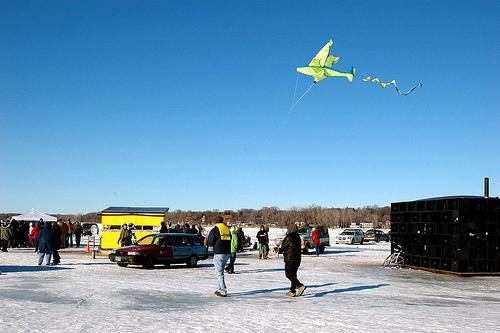Identify any object with a specific shape in the image. There is a kite shaped like an airplane. What is the interaction between the people and the surroundings in the image? The people are walking on the snow on the ground. What are the vehicles present in the image and what are their colors? There is a red and white vehicle, a red and light blue car, a white car, and a maroon car. Describe the natural elements present in the image like ground, sky, and plants. The ground is covered with snow, the sky is clear blue, and there are dried brown plants. Express the sentiment or mood of the image. The image has a joyful and festive vibe with people and colorful kites. Perform a complex reasoning task about the possibility of movement or activity in the image. Since there are people walking on the snow and a kite flying in the sky, it implies that there is some movement and activity happening in the image. What is the number of distinct kites in the image? There are at least three separate kite descriptions, so there might be three distinct kites. Identify the object present in the sky and its color. There is a kite in the sky, which is bright green and light green in color. Please tell me about people's clothing in the image. Some people are wearing black and navy blue jackets, a red jacket, and a person has a pair of faded blue trousers. How many bicycles are there in the image and what's their status? There is one bicycle in the image, which is parked and leaning. Select the correct description of the kite from the following options: a) Light green airplane-shaped kite with a thin curly tail b) Bright red kite shaped like a bird c) Large blue kite with long ribbons a) Light green airplane-shaped kite with a thin curly tail Can you see any text in the image that needs to be read? No text is present in the image. Describe the tail of the kite. thin and curly What is the main activity happening with people in the image? walking on the snow What is the color of the sky in the image? clear blue List three prominent colors of the vehicles in the image. red and light blue, white, maroon Create a short poem inspired by the image, including references to the kite, snow, and colors. Kite of light green hue, up high, / Airplane-shaped of curls, drifting by, / People strolling through soft white snow, / Red, blue, maroon, colors aglow. Choose the correct description of the box from the given options: a) Small black box b) Large orange box c) Transparent box filled with colorful items a) Small black box Can you see a tiny yellow snake slithering across a big rock near the center of the image? A yellow snake and a big rock are not mentioned among the described objects. The instruction uses an interrogative sentence, asking the reader to find the non-existent elements, leading them to search for something that does not exist in the image. What is the color of the kite in the sky? light green Identify the type and condition of the plants in the image. dried and brown What is the color of the jackets of the people in the image? black, navy blue, and red Can you spot three dolphins jumping over a wave near the bottom left corner of the image? No, it's not mentioned in the image. Provide a brief and creative caption for the image including details of the key colored objects. On a clear blue sky day, people walk through snow and admire a light green airplane-shaped kite soaring high above. Identify the expression of the man in the image. Not enough information is provided to determine a facial expression. Which shape is the kite in the sky? shaped like an airplane Describe the position and state of the bicycle in the image. parked and leaning Which event is taking place in the image? No specific event is happening, just people walking on snow and a kite flying. Describe the state of the ground in the image. covered with snow What is the color of the trousers in the image? faded blue There is a pink unicorn with a golden horn playing in a field of flowers at the top right side of the photo. The combination of elements (pink unicorn, golden horn, and field of flowers) is not described in the given image. The instruction utilizes a declarative sentence to assert the presence of the non-existent subject matter, leading the reader astray. What type of vehicle is leaning? bike Is the heel lifted from the ground in the image? Yes or No? Yes 